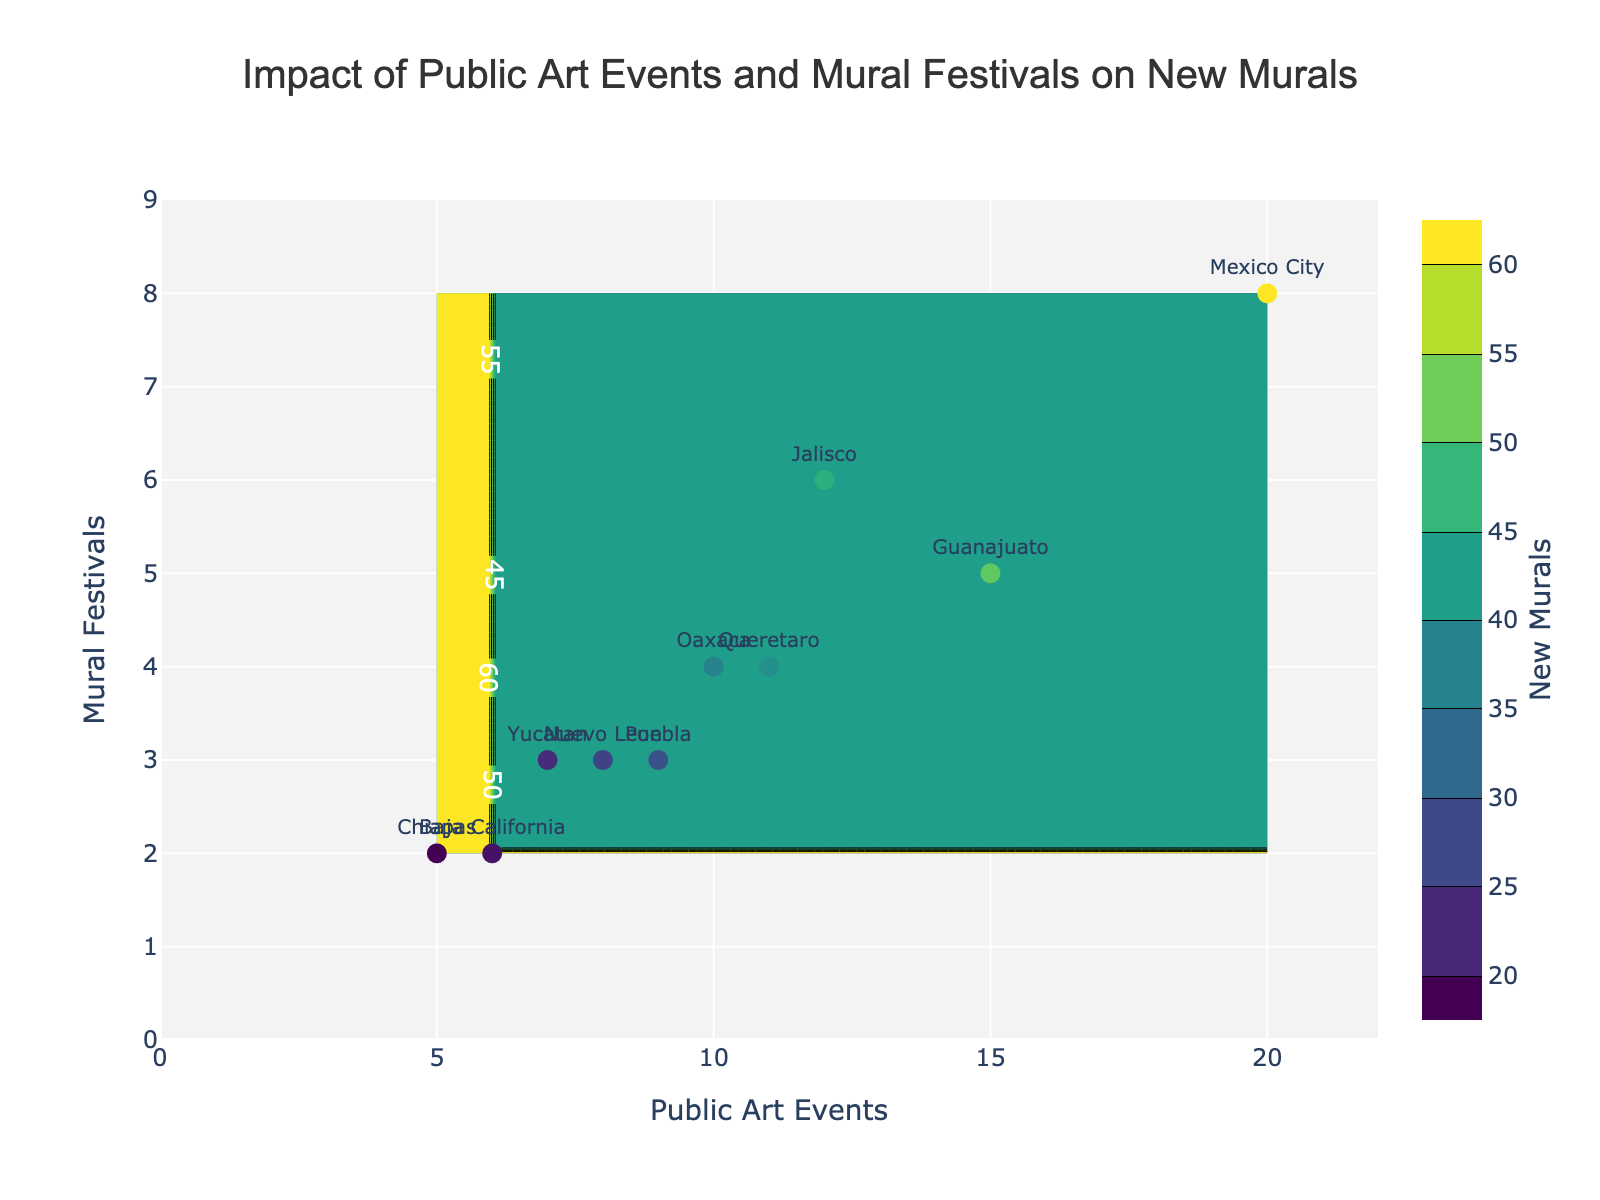What is the title of the plot? The title is located at the top center of the plot and provides an overview of the figure's content.
Answer: Impact of Public Art Events and Mural Festivals on New Murals How many states are represented in the plot? Each label on the scatter plot represents a state, and there are 10 unique labels visible.
Answer: 10 Which state has the highest number of new murals? Look for the state label near the highest value on the color scale and confirm it by the corresponding dot's position on the plot.
Answer: Mexico City What are the axes labeled in the plot? The x-axis and y-axis labels give information about the variables being measured.
Answer: Public Art Events (x-axis) and Mural Festivals (y-axis) What is the color scale representing in the plot? The color scale bar on the right side indicates the variable it represents by the title above it.
Answer: New Murals Which state has the lowest number of public art events? The dot positioned furthest to the left on the x-axis represents the state with the fewest public art events.
Answer: Chiapas How does the frequency of mural festivals correlate with the number of new murals? Observe the general trend on the y-axis and the color scale to see if more frequent festivals tend to result in more new murals.
Answer: Positive correlation Comparing Jalisco and Oaxaca, which has more mural festivals and by how much? Locate both states on the plot and compare their positions on the y-axis, then calculate the difference.
Answer: Jalisco has 2 more mural festivals than Oaxaca For states with 2 mural festivals, what's the range of new murals created? Identify states with 2 mural festivals on the y-axis and see their corresponding color or new murals value.
Answer: 20 to 28 Which state shows these coordinates: 20 Public Art Events and 8 Mural Festivals? This can be found by locating the point (20, 8) on the plot and identifying the label next to it.
Answer: Mexico City 